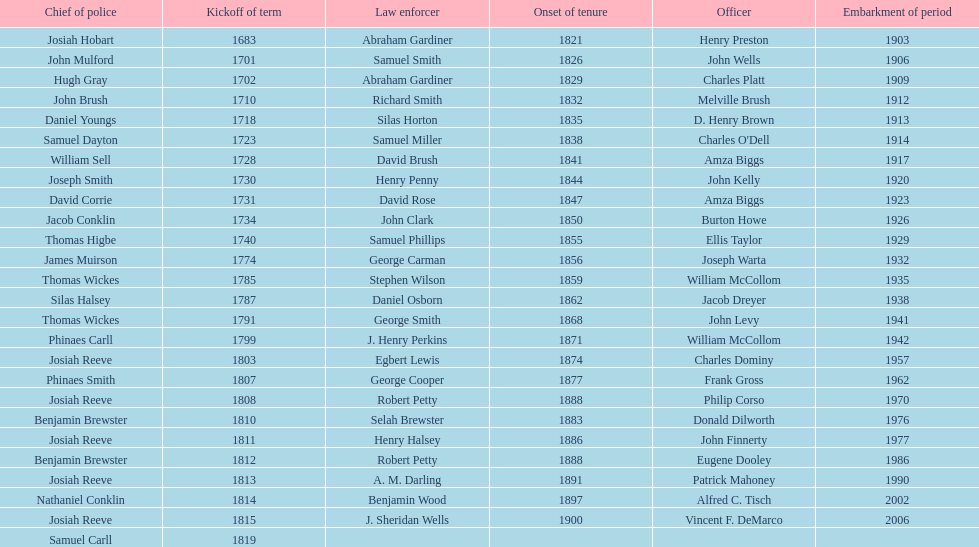How many sheriff's have the last name biggs? 1. 